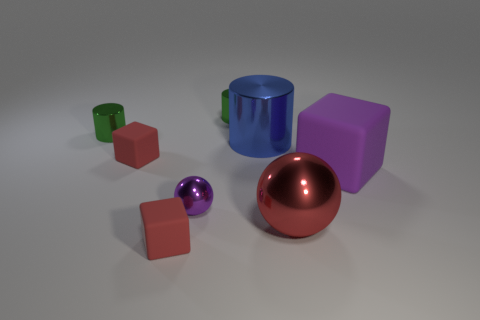Is the color of the large rubber cube the same as the tiny ball?
Provide a short and direct response. Yes. The purple thing left of the purple object right of the tiny shiny thing right of the purple metallic sphere is made of what material?
Ensure brevity in your answer.  Metal. Is the material of the red object that is in front of the big red sphere the same as the large purple thing?
Give a very brief answer. Yes. What number of objects are the same size as the red sphere?
Provide a short and direct response. 2. Is the number of shiny objects behind the large purple object greater than the number of small green cylinders that are to the left of the big blue metal cylinder?
Give a very brief answer. Yes. Are there any small things of the same shape as the large blue metal object?
Give a very brief answer. Yes. There is a cube that is to the right of the red object that is in front of the big ball; how big is it?
Make the answer very short. Large. There is a small purple thing that is behind the sphere that is on the right side of the large thing that is on the left side of the red sphere; what is its shape?
Give a very brief answer. Sphere. What is the size of the purple ball that is made of the same material as the blue cylinder?
Give a very brief answer. Small. Is the number of small purple spheres greater than the number of big red metallic cubes?
Your answer should be compact. Yes. 